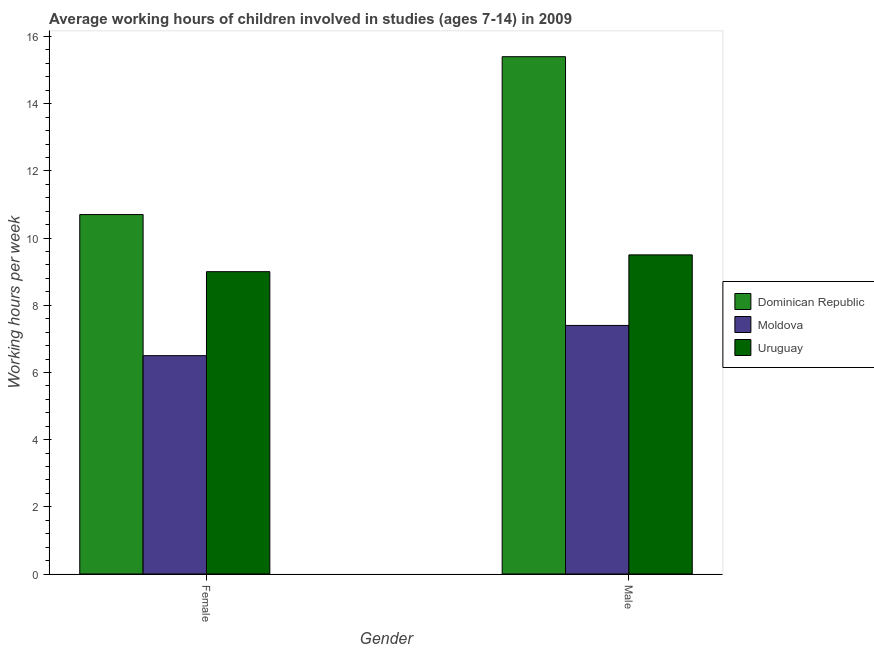How many groups of bars are there?
Offer a terse response. 2. What is the average working hour of female children in Moldova?
Offer a very short reply. 6.5. Across all countries, what is the maximum average working hour of female children?
Give a very brief answer. 10.7. Across all countries, what is the minimum average working hour of male children?
Offer a very short reply. 7.4. In which country was the average working hour of male children maximum?
Offer a terse response. Dominican Republic. In which country was the average working hour of male children minimum?
Your answer should be compact. Moldova. What is the total average working hour of female children in the graph?
Give a very brief answer. 26.2. What is the difference between the average working hour of male children in Moldova and that in Dominican Republic?
Ensure brevity in your answer.  -8. What is the difference between the average working hour of male children in Dominican Republic and the average working hour of female children in Moldova?
Offer a very short reply. 8.9. What is the average average working hour of female children per country?
Your answer should be compact. 8.73. What is the difference between the average working hour of male children and average working hour of female children in Uruguay?
Provide a succinct answer. 0.5. What is the ratio of the average working hour of male children in Dominican Republic to that in Moldova?
Ensure brevity in your answer.  2.08. Is the average working hour of male children in Uruguay less than that in Moldova?
Your answer should be compact. No. In how many countries, is the average working hour of male children greater than the average average working hour of male children taken over all countries?
Make the answer very short. 1. What does the 2nd bar from the left in Female represents?
Provide a succinct answer. Moldova. What does the 3rd bar from the right in Male represents?
Offer a terse response. Dominican Republic. How many bars are there?
Offer a very short reply. 6. Are all the bars in the graph horizontal?
Your response must be concise. No. How many countries are there in the graph?
Your answer should be very brief. 3. What is the difference between two consecutive major ticks on the Y-axis?
Your answer should be very brief. 2. Does the graph contain any zero values?
Offer a terse response. No. How many legend labels are there?
Your answer should be compact. 3. How are the legend labels stacked?
Make the answer very short. Vertical. What is the title of the graph?
Ensure brevity in your answer.  Average working hours of children involved in studies (ages 7-14) in 2009. What is the label or title of the Y-axis?
Your response must be concise. Working hours per week. What is the Working hours per week of Dominican Republic in Male?
Your response must be concise. 15.4. What is the Working hours per week in Moldova in Male?
Keep it short and to the point. 7.4. Across all Gender, what is the maximum Working hours per week in Uruguay?
Offer a terse response. 9.5. Across all Gender, what is the minimum Working hours per week of Dominican Republic?
Provide a succinct answer. 10.7. Across all Gender, what is the minimum Working hours per week in Uruguay?
Your answer should be very brief. 9. What is the total Working hours per week in Dominican Republic in the graph?
Ensure brevity in your answer.  26.1. What is the difference between the Working hours per week in Dominican Republic in Female and that in Male?
Offer a very short reply. -4.7. What is the difference between the Working hours per week in Dominican Republic in Female and the Working hours per week in Moldova in Male?
Provide a succinct answer. 3.3. What is the average Working hours per week of Dominican Republic per Gender?
Offer a very short reply. 13.05. What is the average Working hours per week in Moldova per Gender?
Keep it short and to the point. 6.95. What is the average Working hours per week in Uruguay per Gender?
Give a very brief answer. 9.25. What is the difference between the Working hours per week of Dominican Republic and Working hours per week of Moldova in Male?
Keep it short and to the point. 8. What is the difference between the Working hours per week in Dominican Republic and Working hours per week in Uruguay in Male?
Provide a short and direct response. 5.9. What is the difference between the Working hours per week of Moldova and Working hours per week of Uruguay in Male?
Your answer should be compact. -2.1. What is the ratio of the Working hours per week in Dominican Republic in Female to that in Male?
Keep it short and to the point. 0.69. What is the ratio of the Working hours per week in Moldova in Female to that in Male?
Provide a succinct answer. 0.88. What is the ratio of the Working hours per week of Uruguay in Female to that in Male?
Your answer should be compact. 0.95. What is the difference between the highest and the second highest Working hours per week in Dominican Republic?
Provide a short and direct response. 4.7. What is the difference between the highest and the second highest Working hours per week of Moldova?
Offer a very short reply. 0.9. What is the difference between the highest and the lowest Working hours per week of Dominican Republic?
Ensure brevity in your answer.  4.7. What is the difference between the highest and the lowest Working hours per week of Uruguay?
Make the answer very short. 0.5. 